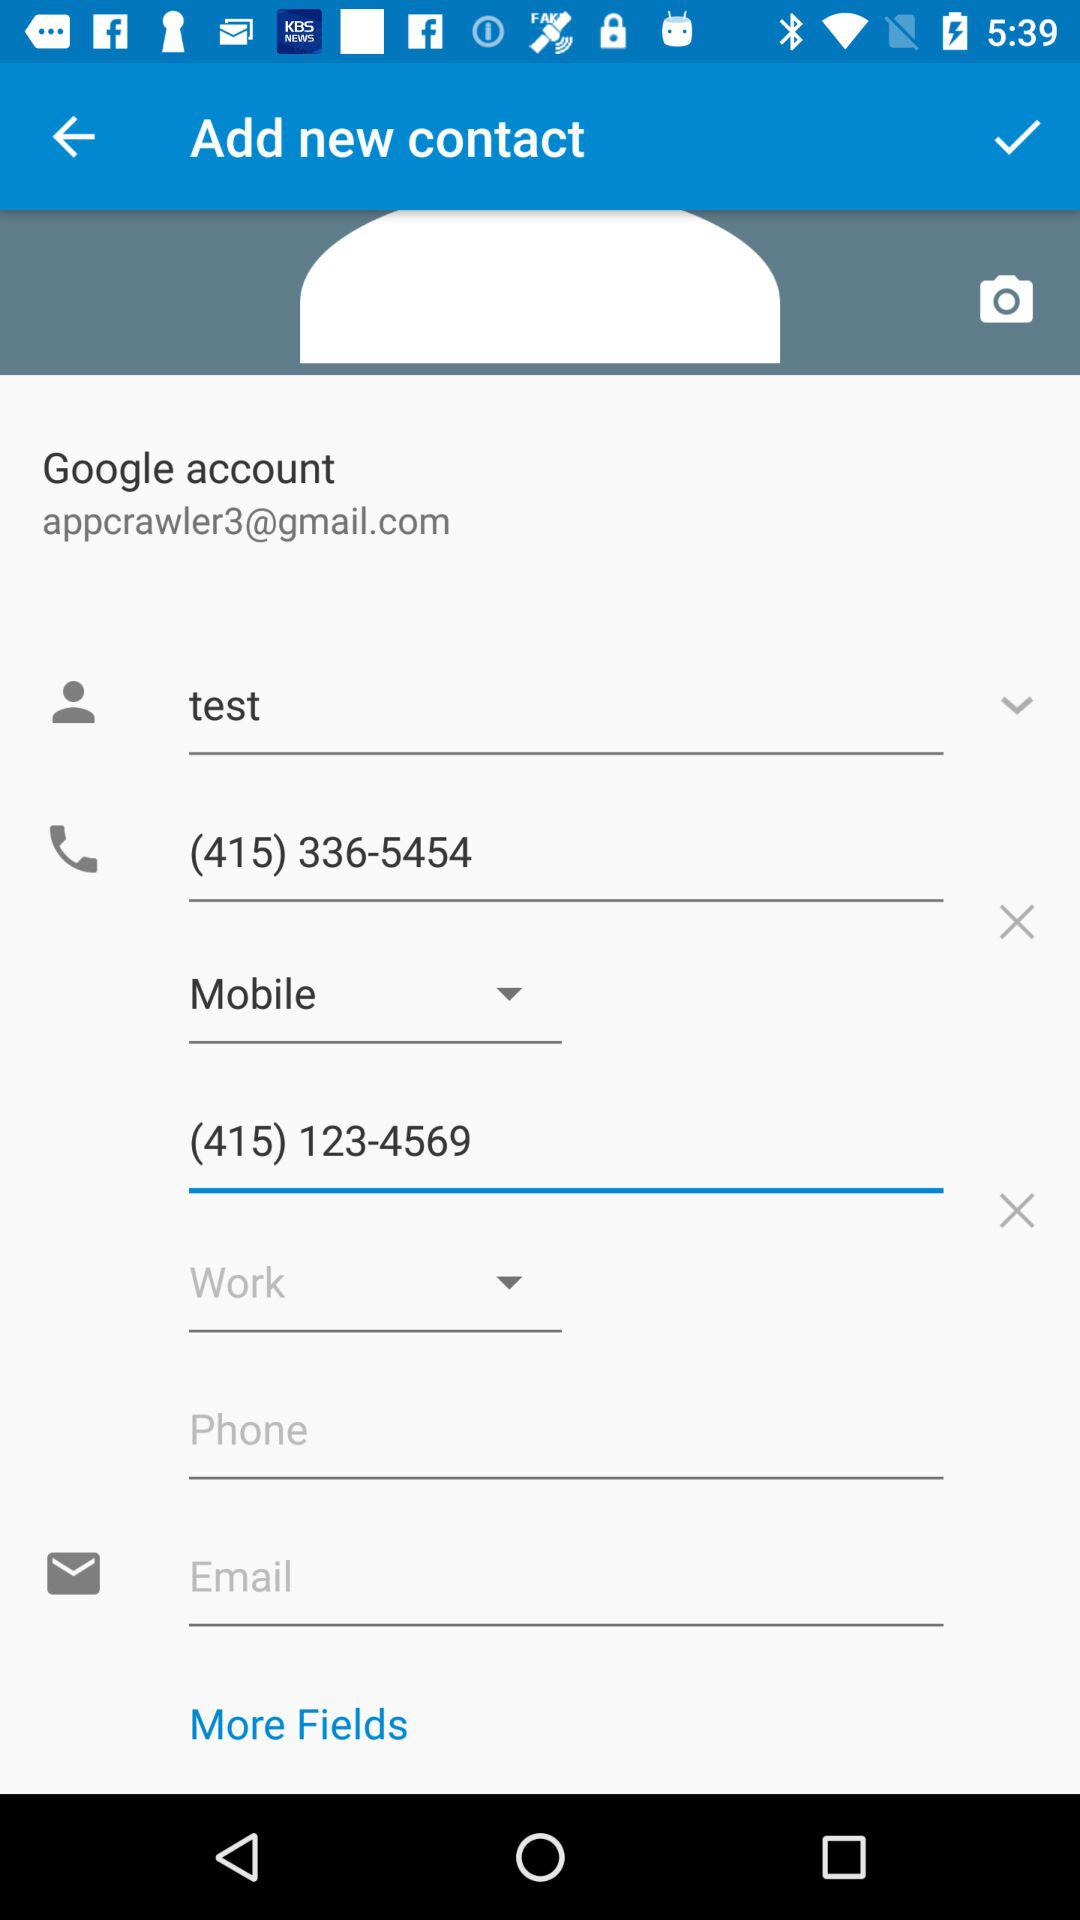What is the mobile number of the user? The mobile number of the user is (415) 336-5454. 